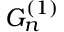<formula> <loc_0><loc_0><loc_500><loc_500>G _ { n } ^ { ( 1 ) }</formula> 